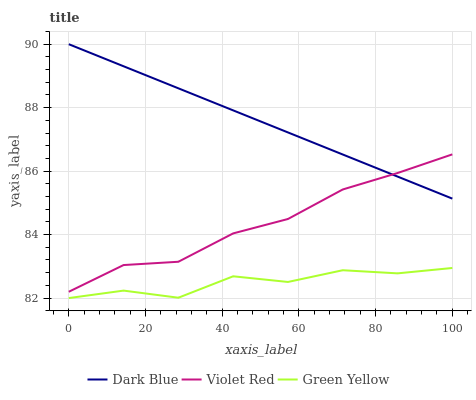Does Violet Red have the minimum area under the curve?
Answer yes or no. No. Does Violet Red have the maximum area under the curve?
Answer yes or no. No. Is Violet Red the smoothest?
Answer yes or no. No. Is Violet Red the roughest?
Answer yes or no. No. Does Violet Red have the lowest value?
Answer yes or no. No. Does Violet Red have the highest value?
Answer yes or no. No. Is Green Yellow less than Dark Blue?
Answer yes or no. Yes. Is Dark Blue greater than Green Yellow?
Answer yes or no. Yes. Does Green Yellow intersect Dark Blue?
Answer yes or no. No. 